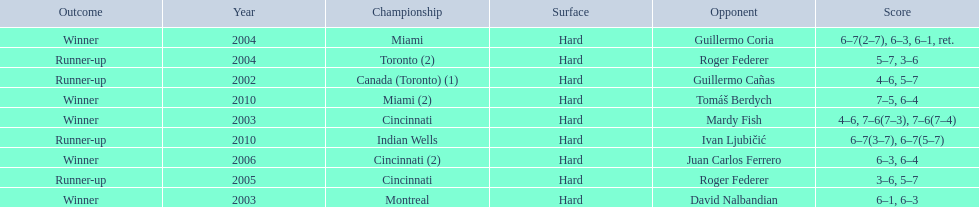How many times were roddick's opponents not from the usa? 8. 